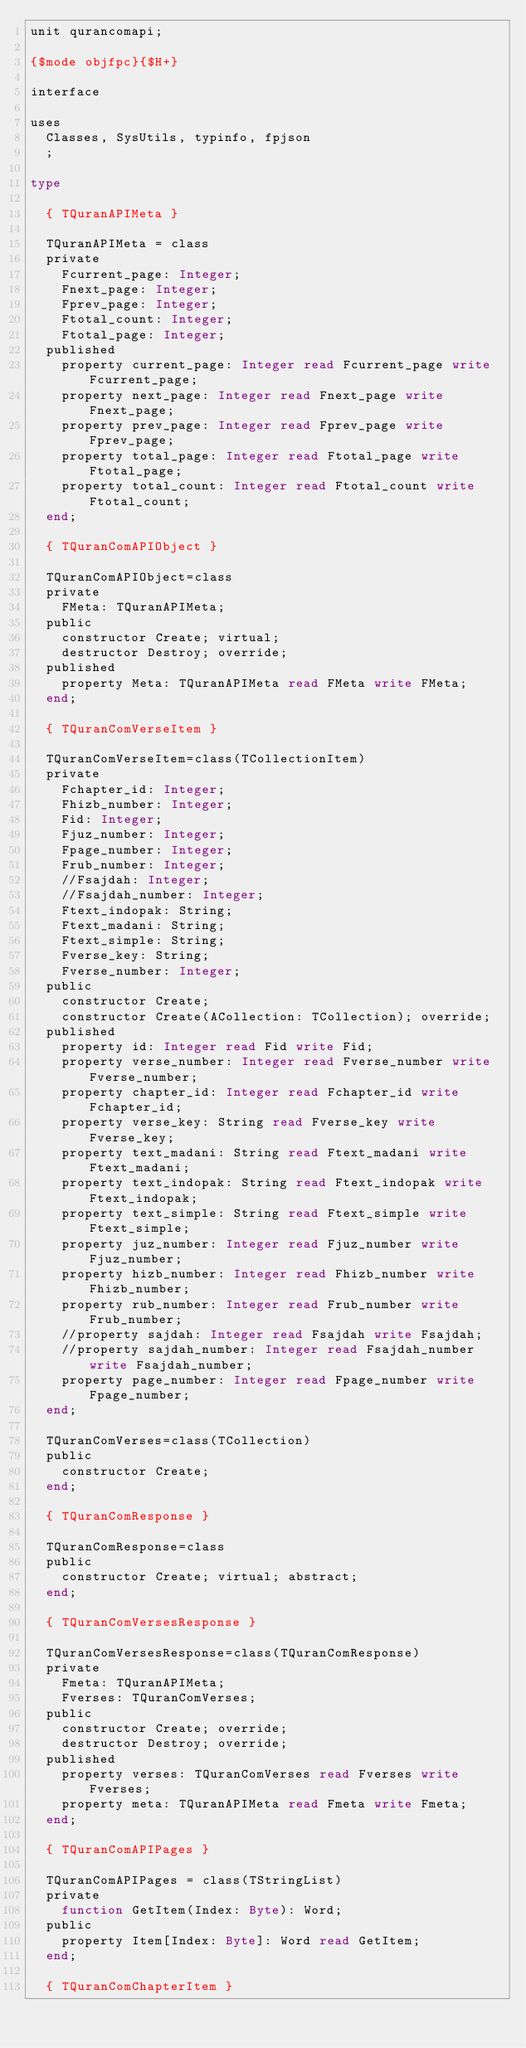<code> <loc_0><loc_0><loc_500><loc_500><_Pascal_>unit qurancomapi;

{$mode objfpc}{$H+}

interface

uses
  Classes, SysUtils, typinfo, fpjson
  ;

type

  { TQuranAPIMeta }

  TQuranAPIMeta = class
  private
    Fcurrent_page: Integer;
    Fnext_page: Integer;
    Fprev_page: Integer;
    Ftotal_count: Integer;
    Ftotal_page: Integer;
  published
    property current_page: Integer read Fcurrent_page write Fcurrent_page;
    property next_page: Integer read Fnext_page write Fnext_page;
    property prev_page: Integer read Fprev_page write Fprev_page;
    property total_page: Integer read Ftotal_page write Ftotal_page;
    property total_count: Integer read Ftotal_count write Ftotal_count;
  end;

  { TQuranComAPIObject }

  TQuranComAPIObject=class
  private
    FMeta: TQuranAPIMeta;
  public
    constructor Create; virtual;
    destructor Destroy; override;
  published
    property Meta: TQuranAPIMeta read FMeta write FMeta;
  end;

  { TQuranComVerseItem }

  TQuranComVerseItem=class(TCollectionItem)
  private
    Fchapter_id: Integer;
    Fhizb_number: Integer;
    Fid: Integer;
    Fjuz_number: Integer;
    Fpage_number: Integer;
    Frub_number: Integer;
    //Fsajdah: Integer;
    //Fsajdah_number: Integer;
    Ftext_indopak: String;
    Ftext_madani: String;
    Ftext_simple: String;
    Fverse_key: String;
    Fverse_number: Integer;
  public
    constructor Create;
    constructor Create(ACollection: TCollection); override;
  published
    property id: Integer read Fid write Fid;
    property verse_number: Integer read Fverse_number write Fverse_number;
    property chapter_id: Integer read Fchapter_id write Fchapter_id;
    property verse_key: String read Fverse_key write Fverse_key;
    property text_madani: String read Ftext_madani write Ftext_madani;
    property text_indopak: String read Ftext_indopak write Ftext_indopak;
    property text_simple: String read Ftext_simple write Ftext_simple;
    property juz_number: Integer read Fjuz_number write Fjuz_number;
    property hizb_number: Integer read Fhizb_number write Fhizb_number;
    property rub_number: Integer read Frub_number write Frub_number;
    //property sajdah: Integer read Fsajdah write Fsajdah;
    //property sajdah_number: Integer read Fsajdah_number write Fsajdah_number;
    property page_number: Integer read Fpage_number write Fpage_number;
  end;

  TQuranComVerses=class(TCollection)
  public
    constructor Create;
  end;

  { TQuranComResponse }

  TQuranComResponse=class
  public
    constructor Create; virtual; abstract;
  end;

  { TQuranComVersesResponse }

  TQuranComVersesResponse=class(TQuranComResponse)
  private
    Fmeta: TQuranAPIMeta;
    Fverses: TQuranComVerses;
  public
    constructor Create; override;
    destructor Destroy; override;
  published
    property verses: TQuranComVerses read Fverses write Fverses;
    property meta: TQuranAPIMeta read Fmeta write Fmeta;
  end;

  { TQuranComAPIPages }

  TQuranComAPIPages = class(TStringList)
  private
    function GetItem(Index: Byte): Word;
  public
    property Item[Index: Byte]: Word read GetItem;
  end;

  { TQuranComChapterItem }
</code> 